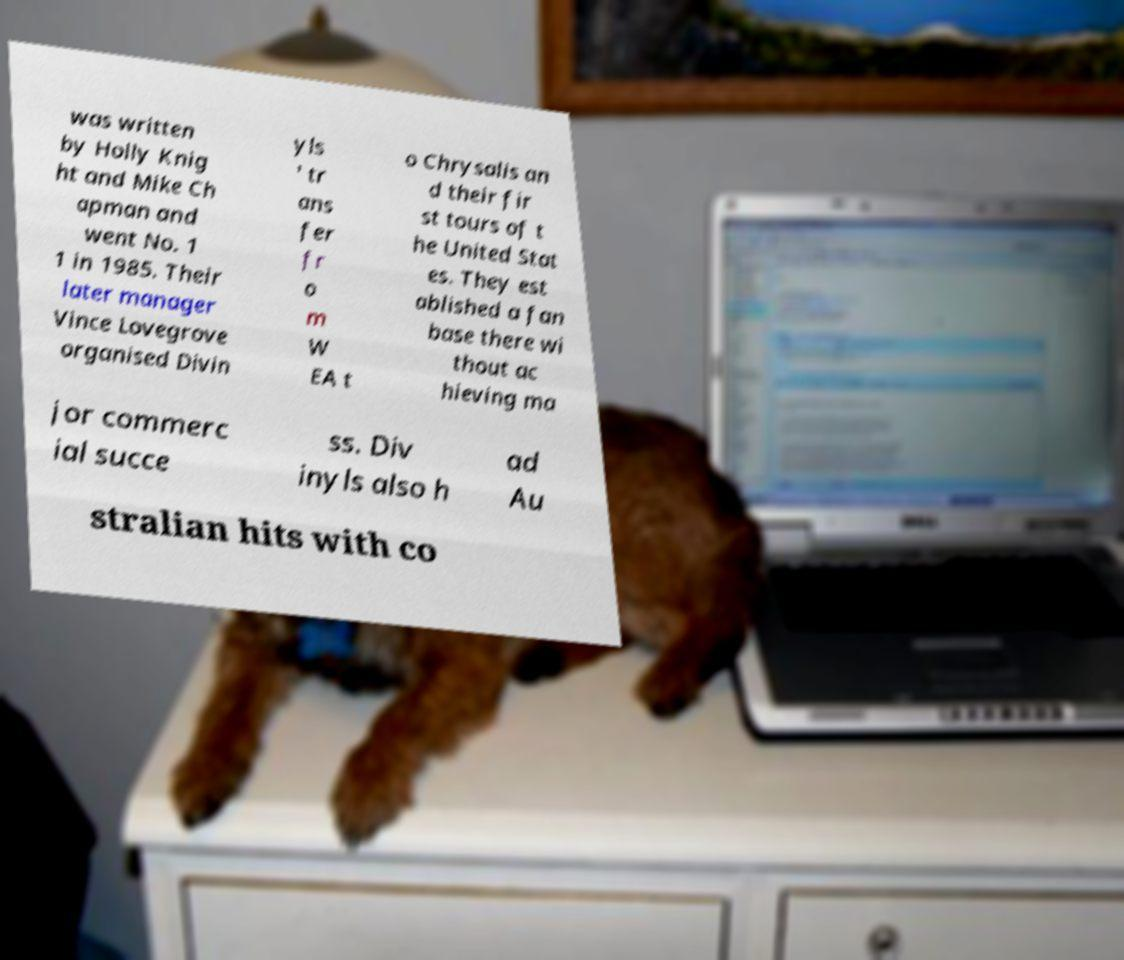I need the written content from this picture converted into text. Can you do that? was written by Holly Knig ht and Mike Ch apman and went No. 1 1 in 1985. Their later manager Vince Lovegrove organised Divin yls ' tr ans fer fr o m W EA t o Chrysalis an d their fir st tours of t he United Stat es. They est ablished a fan base there wi thout ac hieving ma jor commerc ial succe ss. Div inyls also h ad Au stralian hits with co 